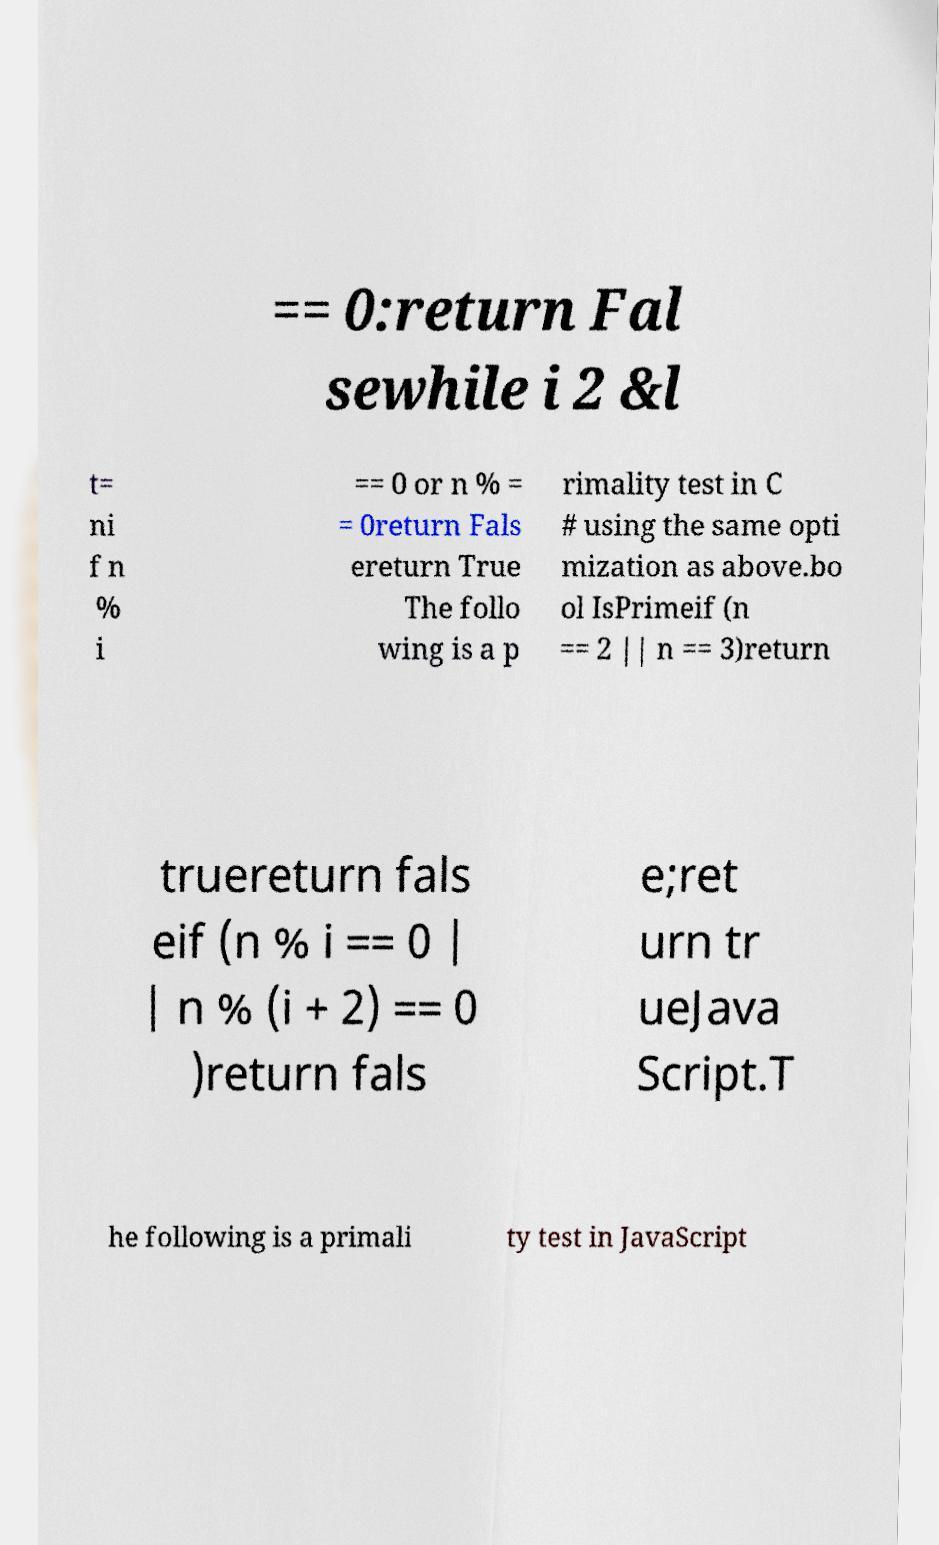There's text embedded in this image that I need extracted. Can you transcribe it verbatim? == 0:return Fal sewhile i 2 &l t= ni f n % i == 0 or n % = = 0return Fals ereturn True The follo wing is a p rimality test in C # using the same opti mization as above.bo ol IsPrimeif (n == 2 || n == 3)return truereturn fals eif (n % i == 0 | | n % (i + 2) == 0 )return fals e;ret urn tr ueJava Script.T he following is a primali ty test in JavaScript 